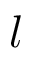<formula> <loc_0><loc_0><loc_500><loc_500>l</formula> 